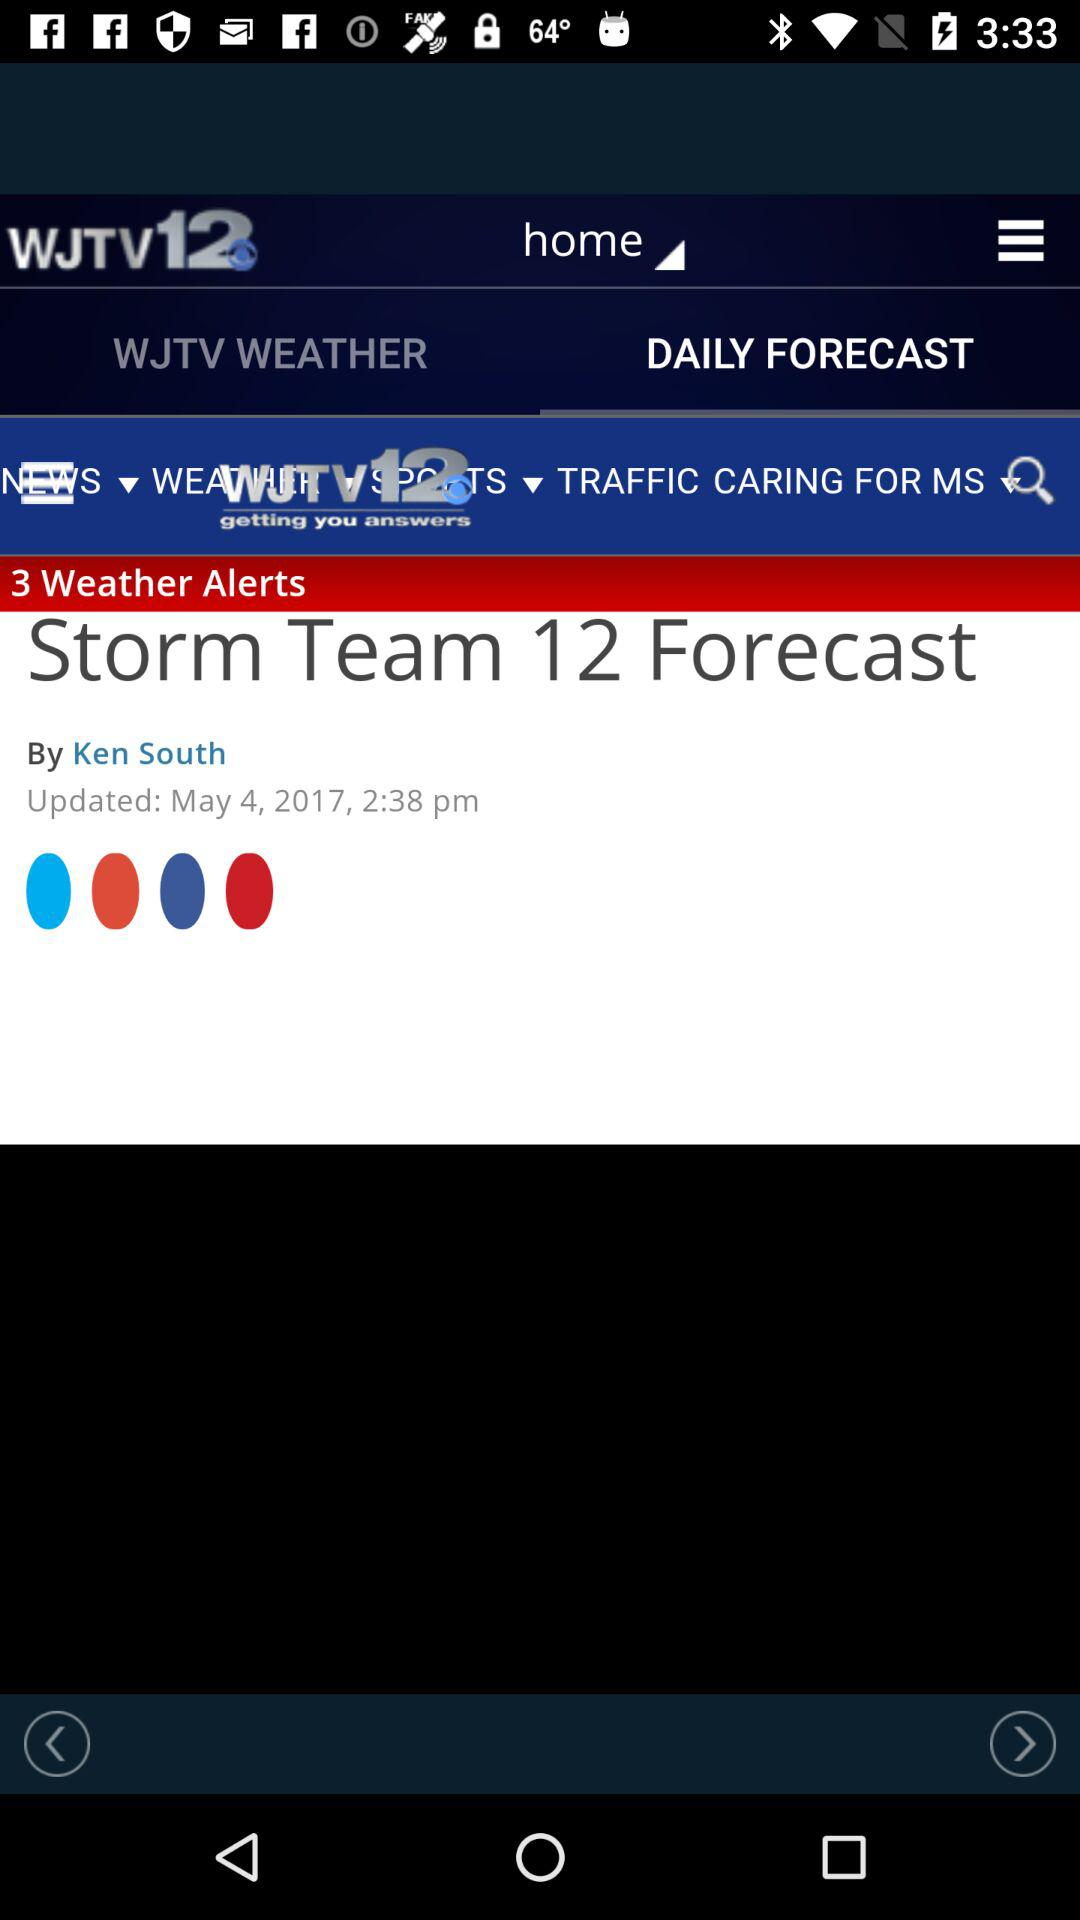Which tab is selected? The selected tab is "DAILY FORECAST". 